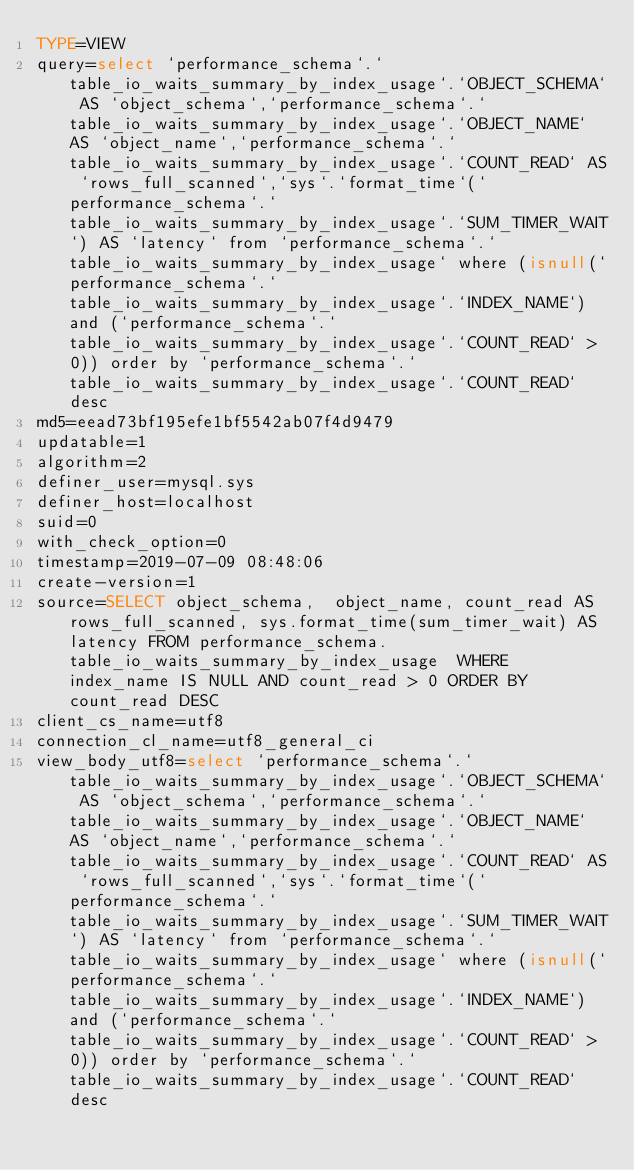Convert code to text. <code><loc_0><loc_0><loc_500><loc_500><_VisualBasic_>TYPE=VIEW
query=select `performance_schema`.`table_io_waits_summary_by_index_usage`.`OBJECT_SCHEMA` AS `object_schema`,`performance_schema`.`table_io_waits_summary_by_index_usage`.`OBJECT_NAME` AS `object_name`,`performance_schema`.`table_io_waits_summary_by_index_usage`.`COUNT_READ` AS `rows_full_scanned`,`sys`.`format_time`(`performance_schema`.`table_io_waits_summary_by_index_usage`.`SUM_TIMER_WAIT`) AS `latency` from `performance_schema`.`table_io_waits_summary_by_index_usage` where (isnull(`performance_schema`.`table_io_waits_summary_by_index_usage`.`INDEX_NAME`) and (`performance_schema`.`table_io_waits_summary_by_index_usage`.`COUNT_READ` > 0)) order by `performance_schema`.`table_io_waits_summary_by_index_usage`.`COUNT_READ` desc
md5=eead73bf195efe1bf5542ab07f4d9479
updatable=1
algorithm=2
definer_user=mysql.sys
definer_host=localhost
suid=0
with_check_option=0
timestamp=2019-07-09 08:48:06
create-version=1
source=SELECT object_schema,  object_name, count_read AS rows_full_scanned, sys.format_time(sum_timer_wait) AS latency FROM performance_schema.table_io_waits_summary_by_index_usage  WHERE index_name IS NULL AND count_read > 0 ORDER BY count_read DESC
client_cs_name=utf8
connection_cl_name=utf8_general_ci
view_body_utf8=select `performance_schema`.`table_io_waits_summary_by_index_usage`.`OBJECT_SCHEMA` AS `object_schema`,`performance_schema`.`table_io_waits_summary_by_index_usage`.`OBJECT_NAME` AS `object_name`,`performance_schema`.`table_io_waits_summary_by_index_usage`.`COUNT_READ` AS `rows_full_scanned`,`sys`.`format_time`(`performance_schema`.`table_io_waits_summary_by_index_usage`.`SUM_TIMER_WAIT`) AS `latency` from `performance_schema`.`table_io_waits_summary_by_index_usage` where (isnull(`performance_schema`.`table_io_waits_summary_by_index_usage`.`INDEX_NAME`) and (`performance_schema`.`table_io_waits_summary_by_index_usage`.`COUNT_READ` > 0)) order by `performance_schema`.`table_io_waits_summary_by_index_usage`.`COUNT_READ` desc
</code> 